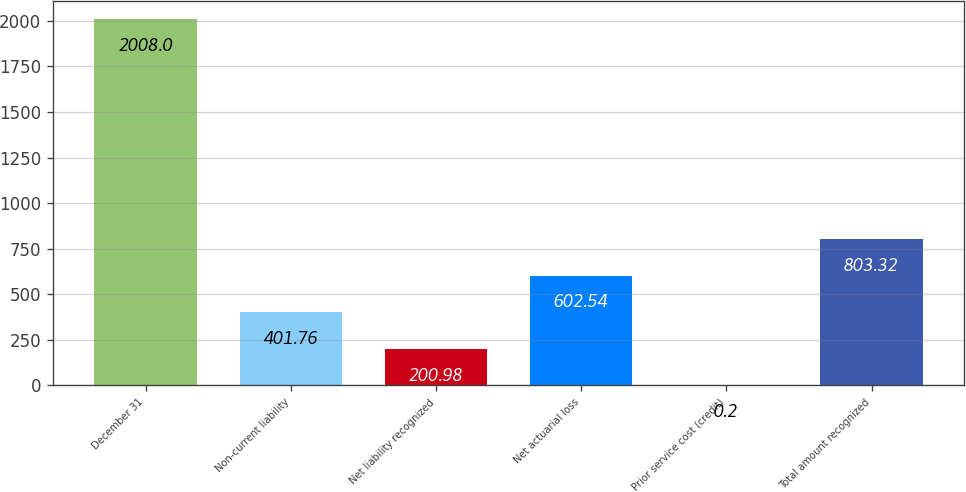<chart> <loc_0><loc_0><loc_500><loc_500><bar_chart><fcel>December 31<fcel>Non-current liability<fcel>Net liability recognized<fcel>Net actuarial loss<fcel>Prior service cost (credit)<fcel>Total amount recognized<nl><fcel>2008<fcel>401.76<fcel>200.98<fcel>602.54<fcel>0.2<fcel>803.32<nl></chart> 